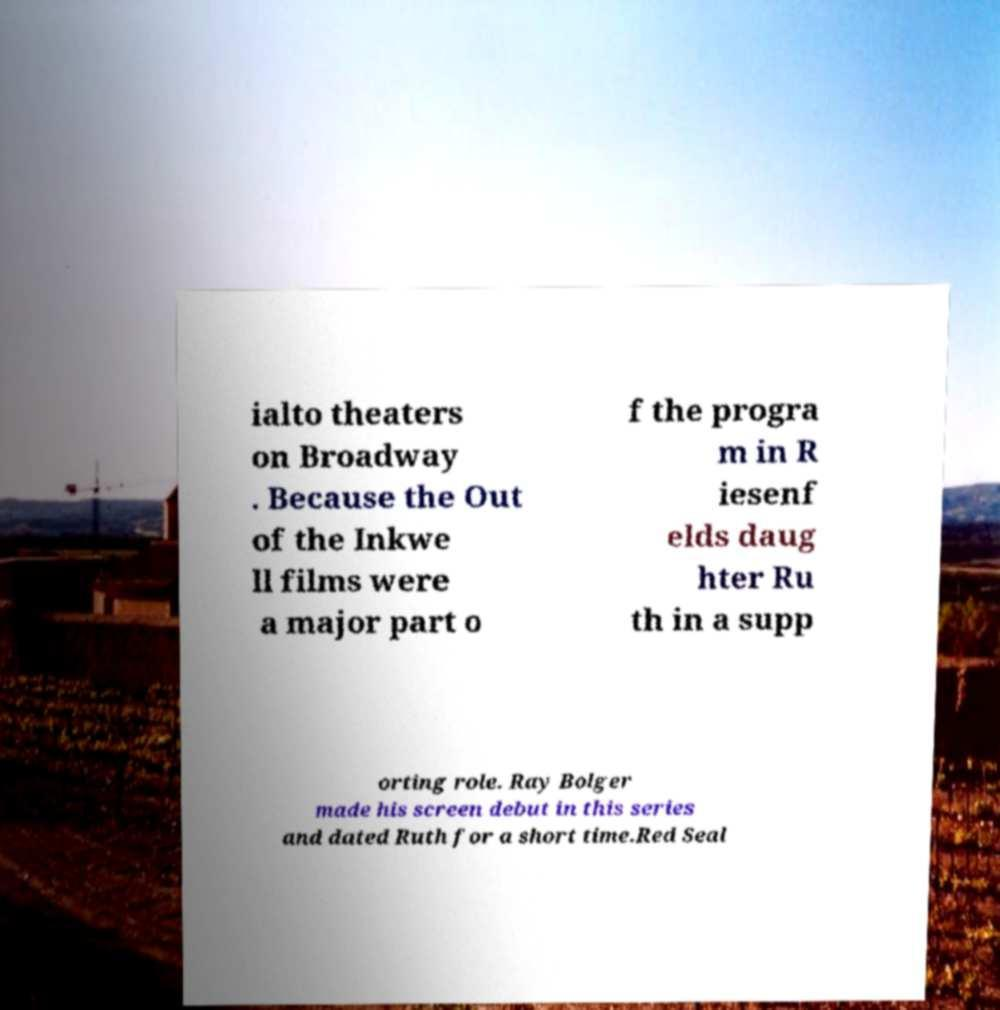Can you accurately transcribe the text from the provided image for me? ialto theaters on Broadway . Because the Out of the Inkwe ll films were a major part o f the progra m in R iesenf elds daug hter Ru th in a supp orting role. Ray Bolger made his screen debut in this series and dated Ruth for a short time.Red Seal 